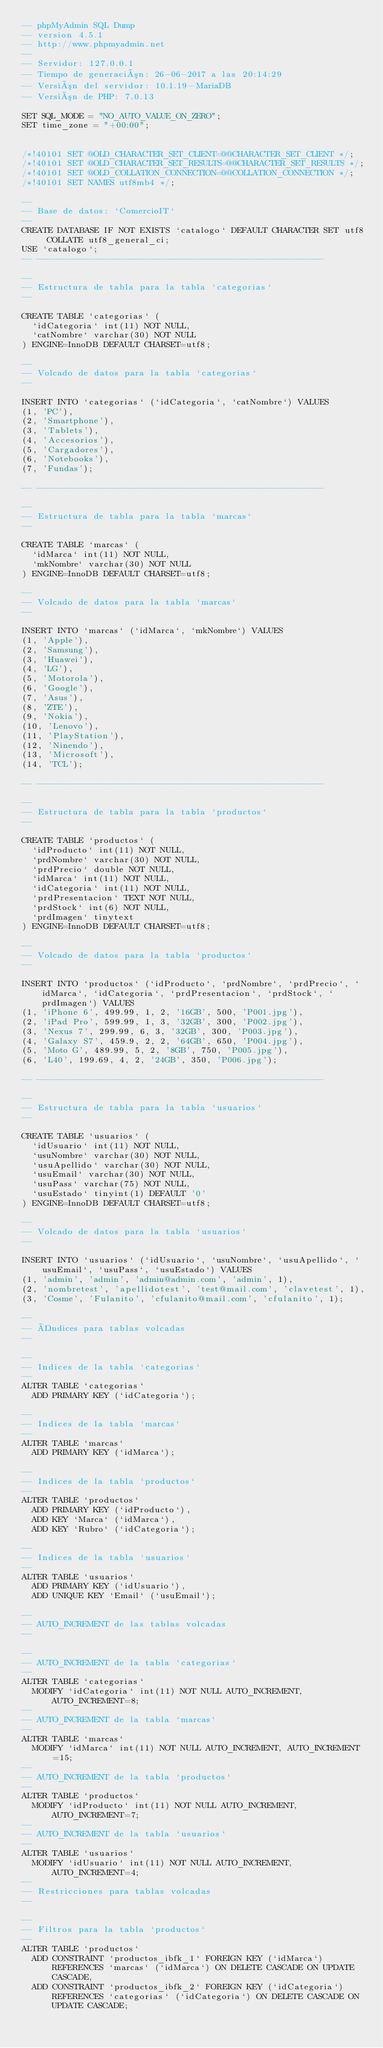Convert code to text. <code><loc_0><loc_0><loc_500><loc_500><_SQL_>-- phpMyAdmin SQL Dump
-- version 4.5.1
-- http://www.phpmyadmin.net
--
-- Servidor: 127.0.0.1
-- Tiempo de generación: 26-06-2017 a las 20:14:29
-- Versión del servidor: 10.1.19-MariaDB
-- Versión de PHP: 7.0.13

SET SQL_MODE = "NO_AUTO_VALUE_ON_ZERO";
SET time_zone = "+00:00";


/*!40101 SET @OLD_CHARACTER_SET_CLIENT=@@CHARACTER_SET_CLIENT */;
/*!40101 SET @OLD_CHARACTER_SET_RESULTS=@@CHARACTER_SET_RESULTS */;
/*!40101 SET @OLD_COLLATION_CONNECTION=@@COLLATION_CONNECTION */;
/*!40101 SET NAMES utf8mb4 */;

--
-- Base de datos: `ComercioIT`
--
CREATE DATABASE IF NOT EXISTS `catalogo` DEFAULT CHARACTER SET utf8 COLLATE utf8_general_ci;
USE `catalogo`;
-- --------------------------------------------------------

--
-- Estructura de tabla para la tabla `categorias`
--

CREATE TABLE `categorias` (
  `idCategoria` int(11) NOT NULL,
  `catNombre` varchar(30) NOT NULL
) ENGINE=InnoDB DEFAULT CHARSET=utf8;

--
-- Volcado de datos para la tabla `categorias`
--

INSERT INTO `categorias` (`idCategoria`, `catNombre`) VALUES
(1, 'PC'),
(2, 'Smartphone'),
(3, 'Tablets'),
(4, 'Accesorios'),
(5, 'Cargadores'),
(6, 'Notebooks'),
(7, 'Fundas');

-- --------------------------------------------------------

--
-- Estructura de tabla para la tabla `marcas`
--

CREATE TABLE `marcas` (
  `idMarca` int(11) NOT NULL,
  `mkNombre` varchar(30) NOT NULL
) ENGINE=InnoDB DEFAULT CHARSET=utf8;

--
-- Volcado de datos para la tabla `marcas`
--

INSERT INTO `marcas` (`idMarca`, `mkNombre`) VALUES
(1, 'Apple'),
(2, 'Samsung'),
(3, 'Huawei'),
(4, 'LG'),
(5, 'Motorola'),
(6, 'Google'),
(7, 'Asus'),
(8, 'ZTE'),
(9, 'Nokia'),
(10, 'Lenovo'),
(11, 'PlayStation'),
(12, 'Ninendo'),
(13, 'Microsoft'),
(14, 'TCL');

-- --------------------------------------------------------

--
-- Estructura de tabla para la tabla `productos`
--

CREATE TABLE `productos` (
  `idProducto` int(11) NOT NULL,
  `prdNombre` varchar(30) NOT NULL,
  `prdPrecio` double NOT NULL,
  `idMarca` int(11) NOT NULL,
  `idCategoria` int(11) NOT NULL,
  `prdPresentacion` TEXT NOT NULL,
  `prdStock` int(6) NOT NULL,
  `prdImagen` tinytext
) ENGINE=InnoDB DEFAULT CHARSET=utf8;

--
-- Volcado de datos para la tabla `productos`
--

INSERT INTO `productos` (`idProducto`, `prdNombre`, `prdPrecio`, `idMarca`, `idCategoria`, `prdPresentacion`, `prdStock`, `prdImagen`) VALUES
(1, 'iPhone 6', 499.99, 1, 2, '16GB', 500, 'P001.jpg'),
(2, 'iPad Pro', 599.99, 1, 3, '32GB', 300, 'P002.jpg'),
(3, 'Nexus 7', 299.99, 6, 3, '32GB', 300, 'P003.jpg'),
(4, 'Galaxy S7', 459.9, 2, 2, '64GB', 650, 'P004.jpg'),
(5, 'Moto G', 489.99, 5, 2, '8GB', 750, 'P005.jpg'),
(6, 'L40', 199.69, 4, 2, '24GB', 350, 'P006.jpg');

-- --------------------------------------------------------

--
-- Estructura de tabla para la tabla `usuarios`
--

CREATE TABLE `usuarios` (
  `idUsuario` int(11) NOT NULL,
  `usuNombre` varchar(30) NOT NULL,
  `usuApellido` varchar(30) NOT NULL,
  `usuEmail` varchar(30) NOT NULL,
  `usuPass` varchar(75) NOT NULL,
  `usuEstado` tinyint(1) DEFAULT '0'
) ENGINE=InnoDB DEFAULT CHARSET=utf8;

--
-- Volcado de datos para la tabla `usuarios`
--

INSERT INTO `usuarios` (`idUsuario`, `usuNombre`, `usuApellido`, `usuEmail`, `usuPass`, `usuEstado`) VALUES
(1, 'admin', 'admin', 'admin@admin.com', 'admin', 1),
(2, 'nombretest', 'apellidotest', 'test@mail.com', 'clavetest', 1),
(3, 'Cosme', 'Fulanito', 'cfulanito@mail.com', 'cfulanito', 1);

--
-- Índices para tablas volcadas
--

--
-- Indices de la tabla `categorias`
--
ALTER TABLE `categorias`
  ADD PRIMARY KEY (`idCategoria`);

--
-- Indices de la tabla `marcas`
--
ALTER TABLE `marcas`
  ADD PRIMARY KEY (`idMarca`);

--
-- Indices de la tabla `productos`
--
ALTER TABLE `productos`
  ADD PRIMARY KEY (`idProducto`),
  ADD KEY `Marca` (`idMarca`),
  ADD KEY `Rubro` (`idCategoria`);

--
-- Indices de la tabla `usuarios`
--
ALTER TABLE `usuarios`
  ADD PRIMARY KEY (`idUsuario`),
  ADD UNIQUE KEY `Email` (`usuEmail`);

--
-- AUTO_INCREMENT de las tablas volcadas
--

--
-- AUTO_INCREMENT de la tabla `categorias`
--
ALTER TABLE `categorias`
  MODIFY `idCategoria` int(11) NOT NULL AUTO_INCREMENT, AUTO_INCREMENT=8;
--
-- AUTO_INCREMENT de la tabla `marcas`
--
ALTER TABLE `marcas`
  MODIFY `idMarca` int(11) NOT NULL AUTO_INCREMENT, AUTO_INCREMENT=15;
--
-- AUTO_INCREMENT de la tabla `productos`
--
ALTER TABLE `productos`
  MODIFY `idProducto` int(11) NOT NULL AUTO_INCREMENT, AUTO_INCREMENT=7;
--
-- AUTO_INCREMENT de la tabla `usuarios`
--
ALTER TABLE `usuarios`
  MODIFY `idUsuario` int(11) NOT NULL AUTO_INCREMENT, AUTO_INCREMENT=4;
--
-- Restricciones para tablas volcadas
--

--
-- Filtros para la tabla `productos`
--
ALTER TABLE `productos`
  ADD CONSTRAINT `productos_ibfk_1` FOREIGN KEY (`idMarca`) REFERENCES `marcas` (`idMarca`) ON DELETE CASCADE ON UPDATE CASCADE,
  ADD CONSTRAINT `productos_ibfk_2` FOREIGN KEY (`idCategoria`) REFERENCES `categorias` (`idCategoria`) ON DELETE CASCADE ON UPDATE CASCADE;
</code> 